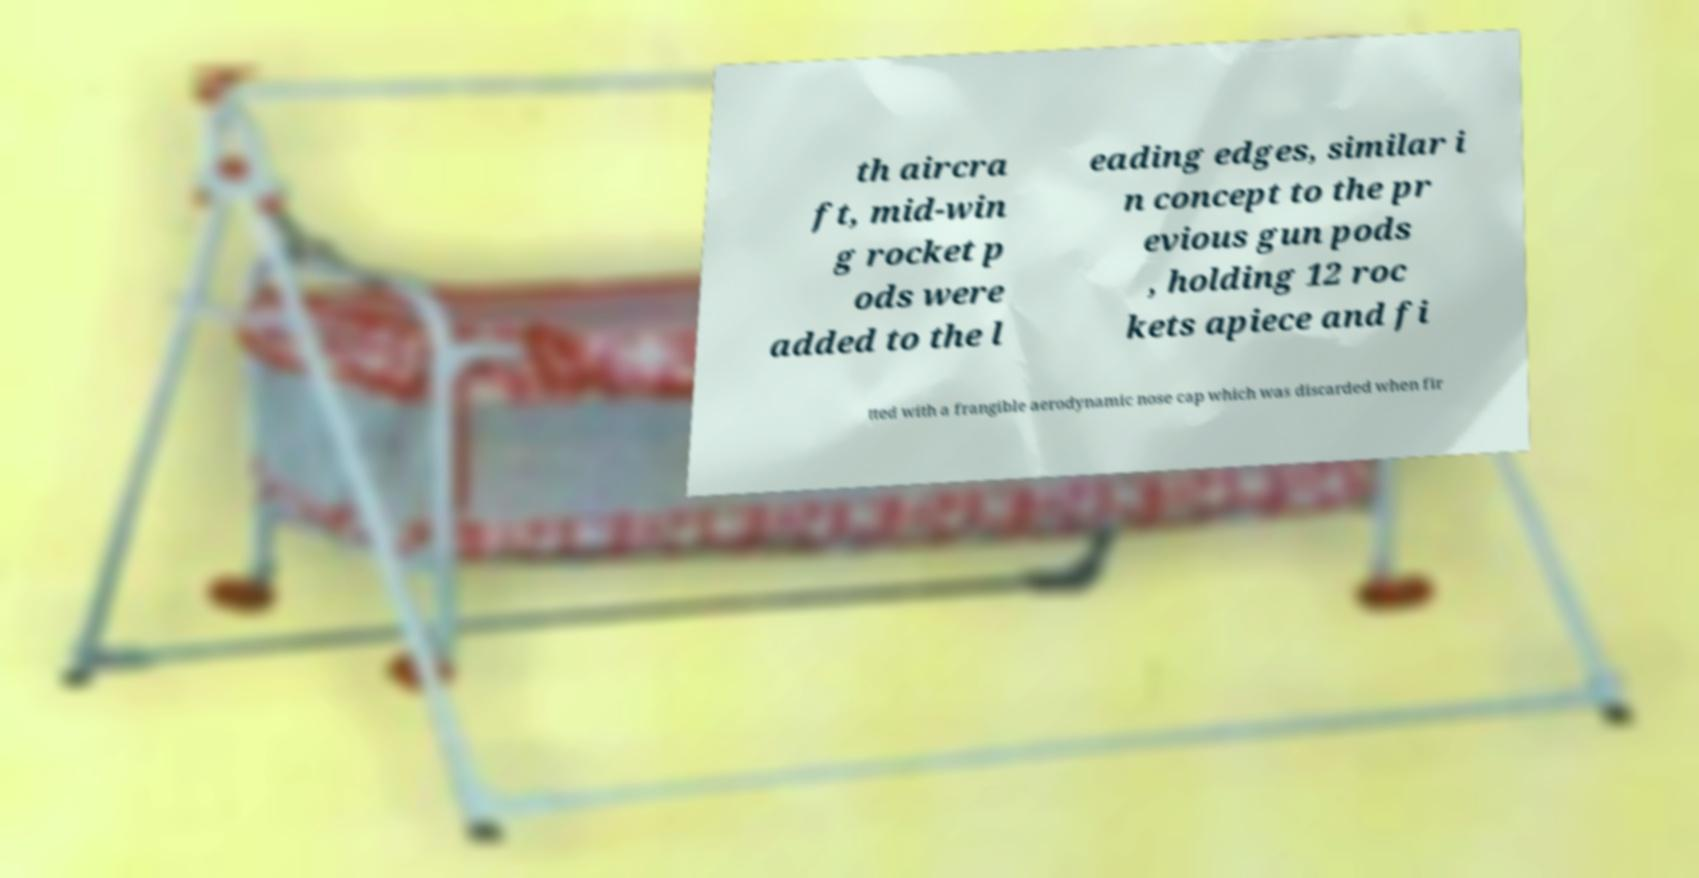There's text embedded in this image that I need extracted. Can you transcribe it verbatim? th aircra ft, mid-win g rocket p ods were added to the l eading edges, similar i n concept to the pr evious gun pods , holding 12 roc kets apiece and fi tted with a frangible aerodynamic nose cap which was discarded when fir 